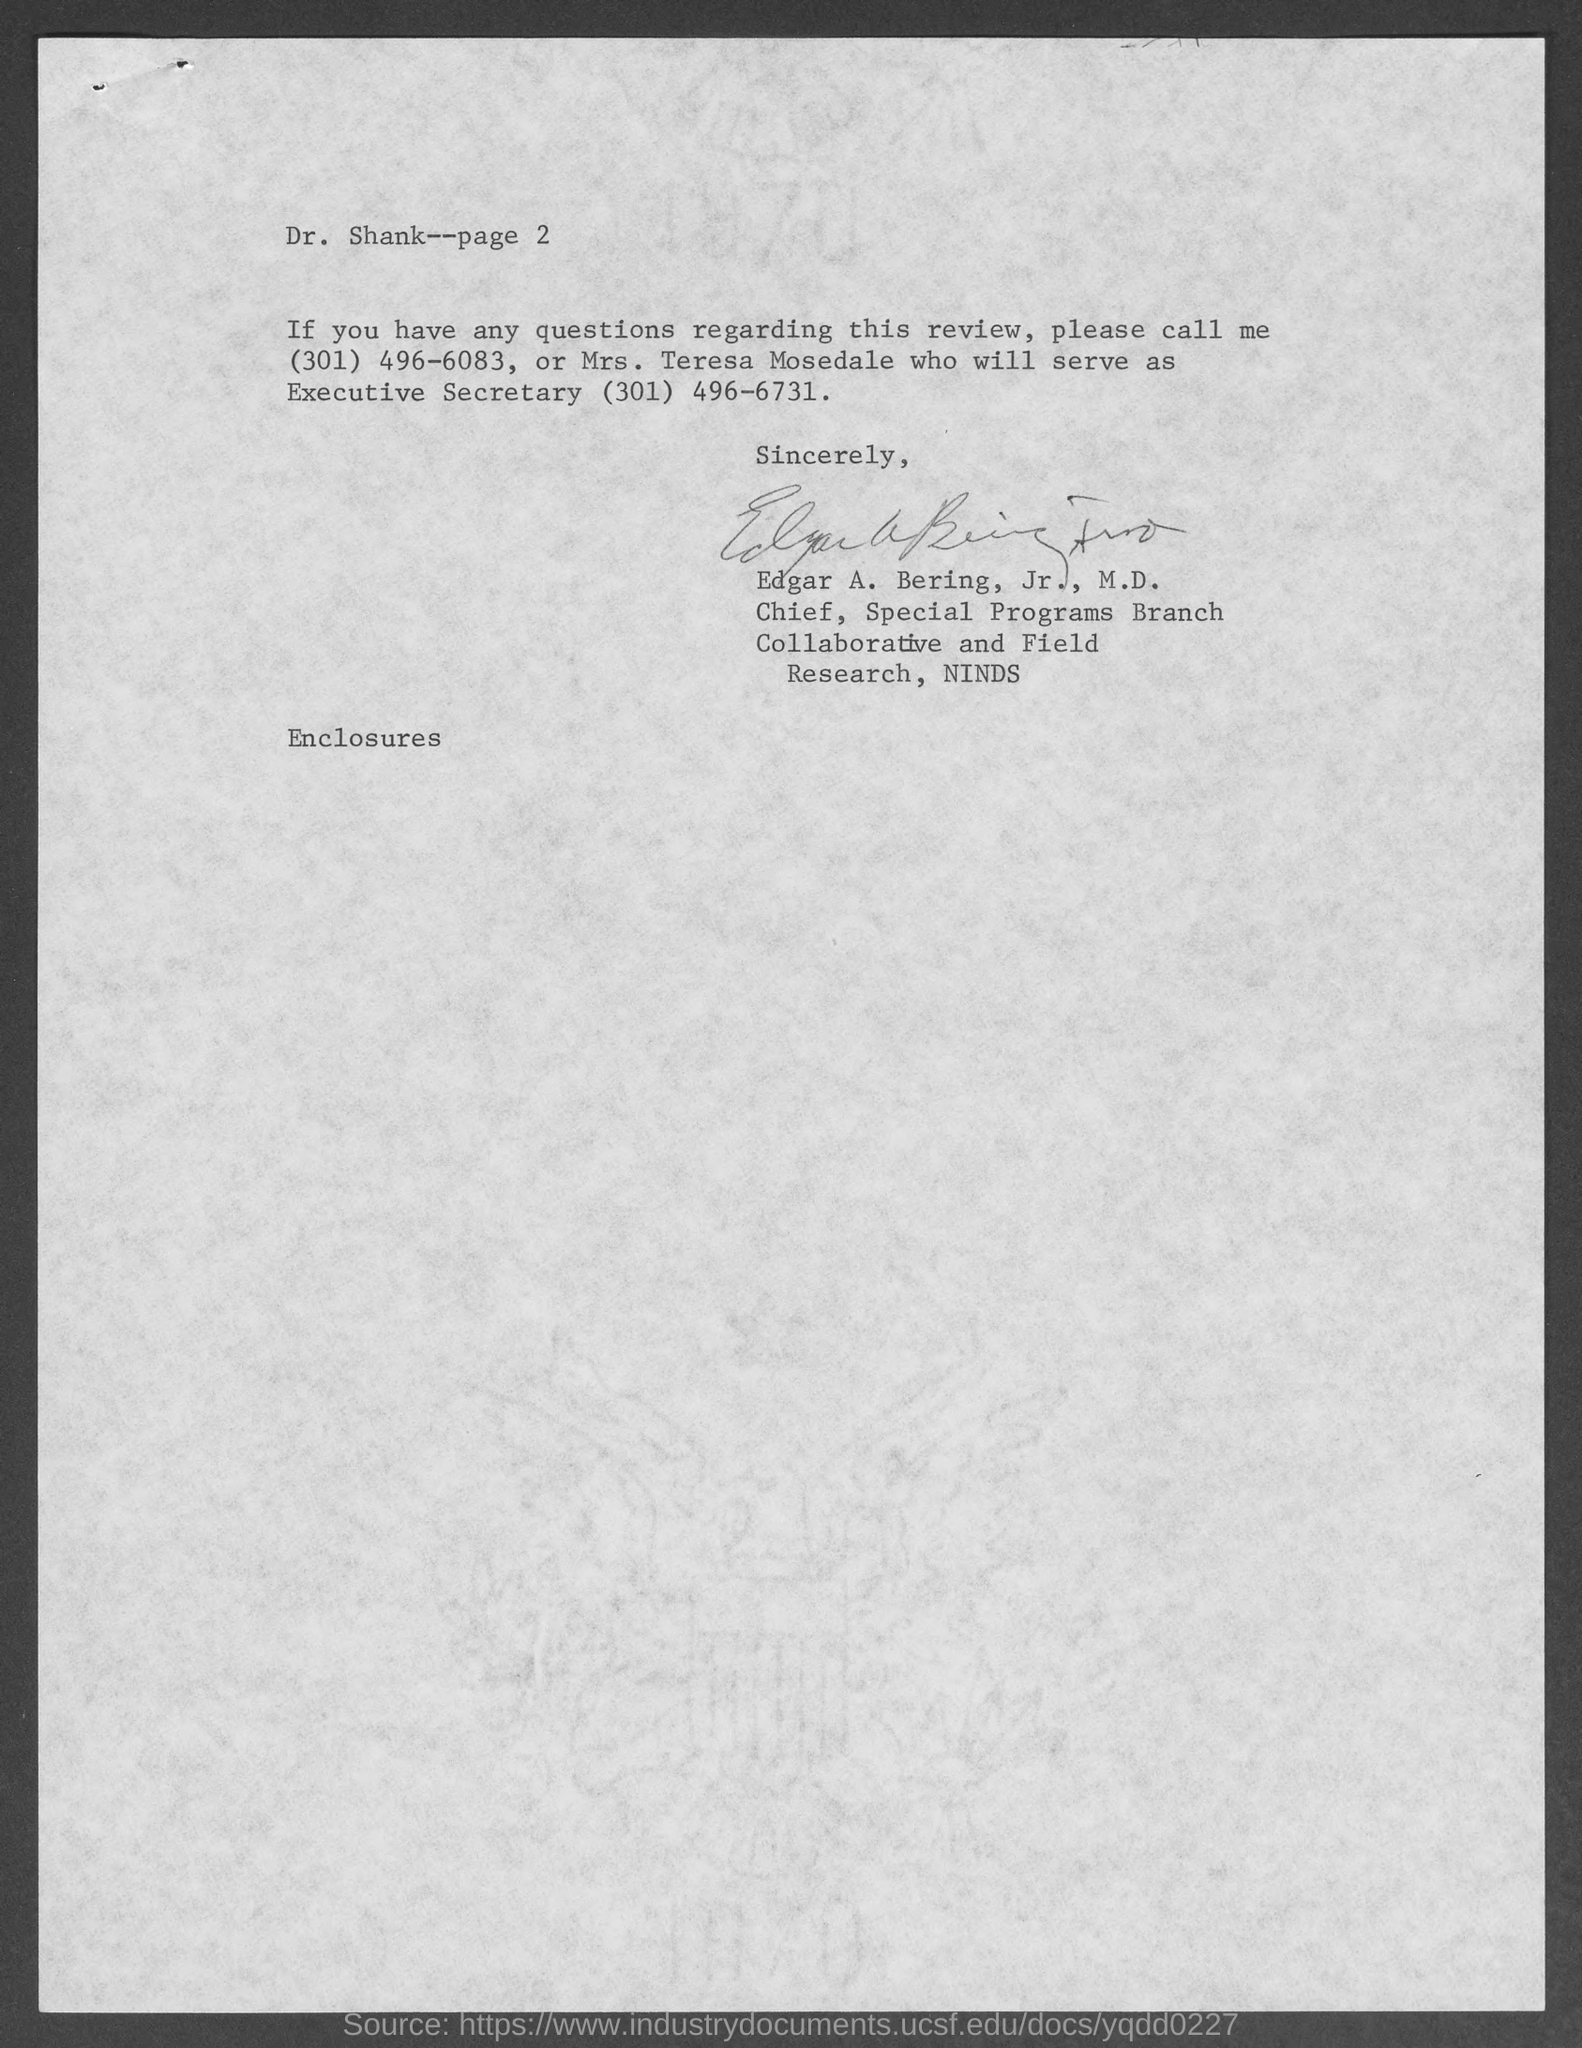Specify some key components in this picture. The page number at the top of the page is 2. In the letter, the person referred to as "you" is Dr. Shank. The letter was written by Edgar A. Bering, Jr., M.D. 